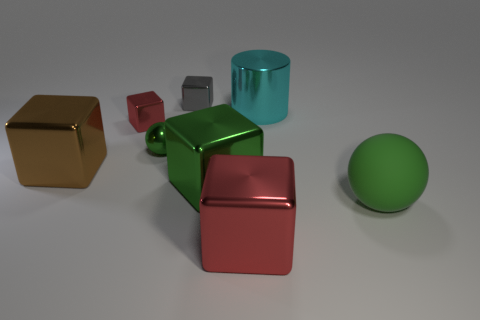Subtract all brown blocks. How many blocks are left? 4 Subtract 1 blocks. How many blocks are left? 4 Subtract all small blocks. How many blocks are left? 3 Subtract all purple cubes. Subtract all purple balls. How many cubes are left? 5 Add 2 tiny metal spheres. How many objects exist? 10 Subtract all cylinders. How many objects are left? 7 Add 8 big balls. How many big balls exist? 9 Subtract 1 cyan cylinders. How many objects are left? 7 Subtract all spheres. Subtract all small metallic things. How many objects are left? 3 Add 4 brown cubes. How many brown cubes are left? 5 